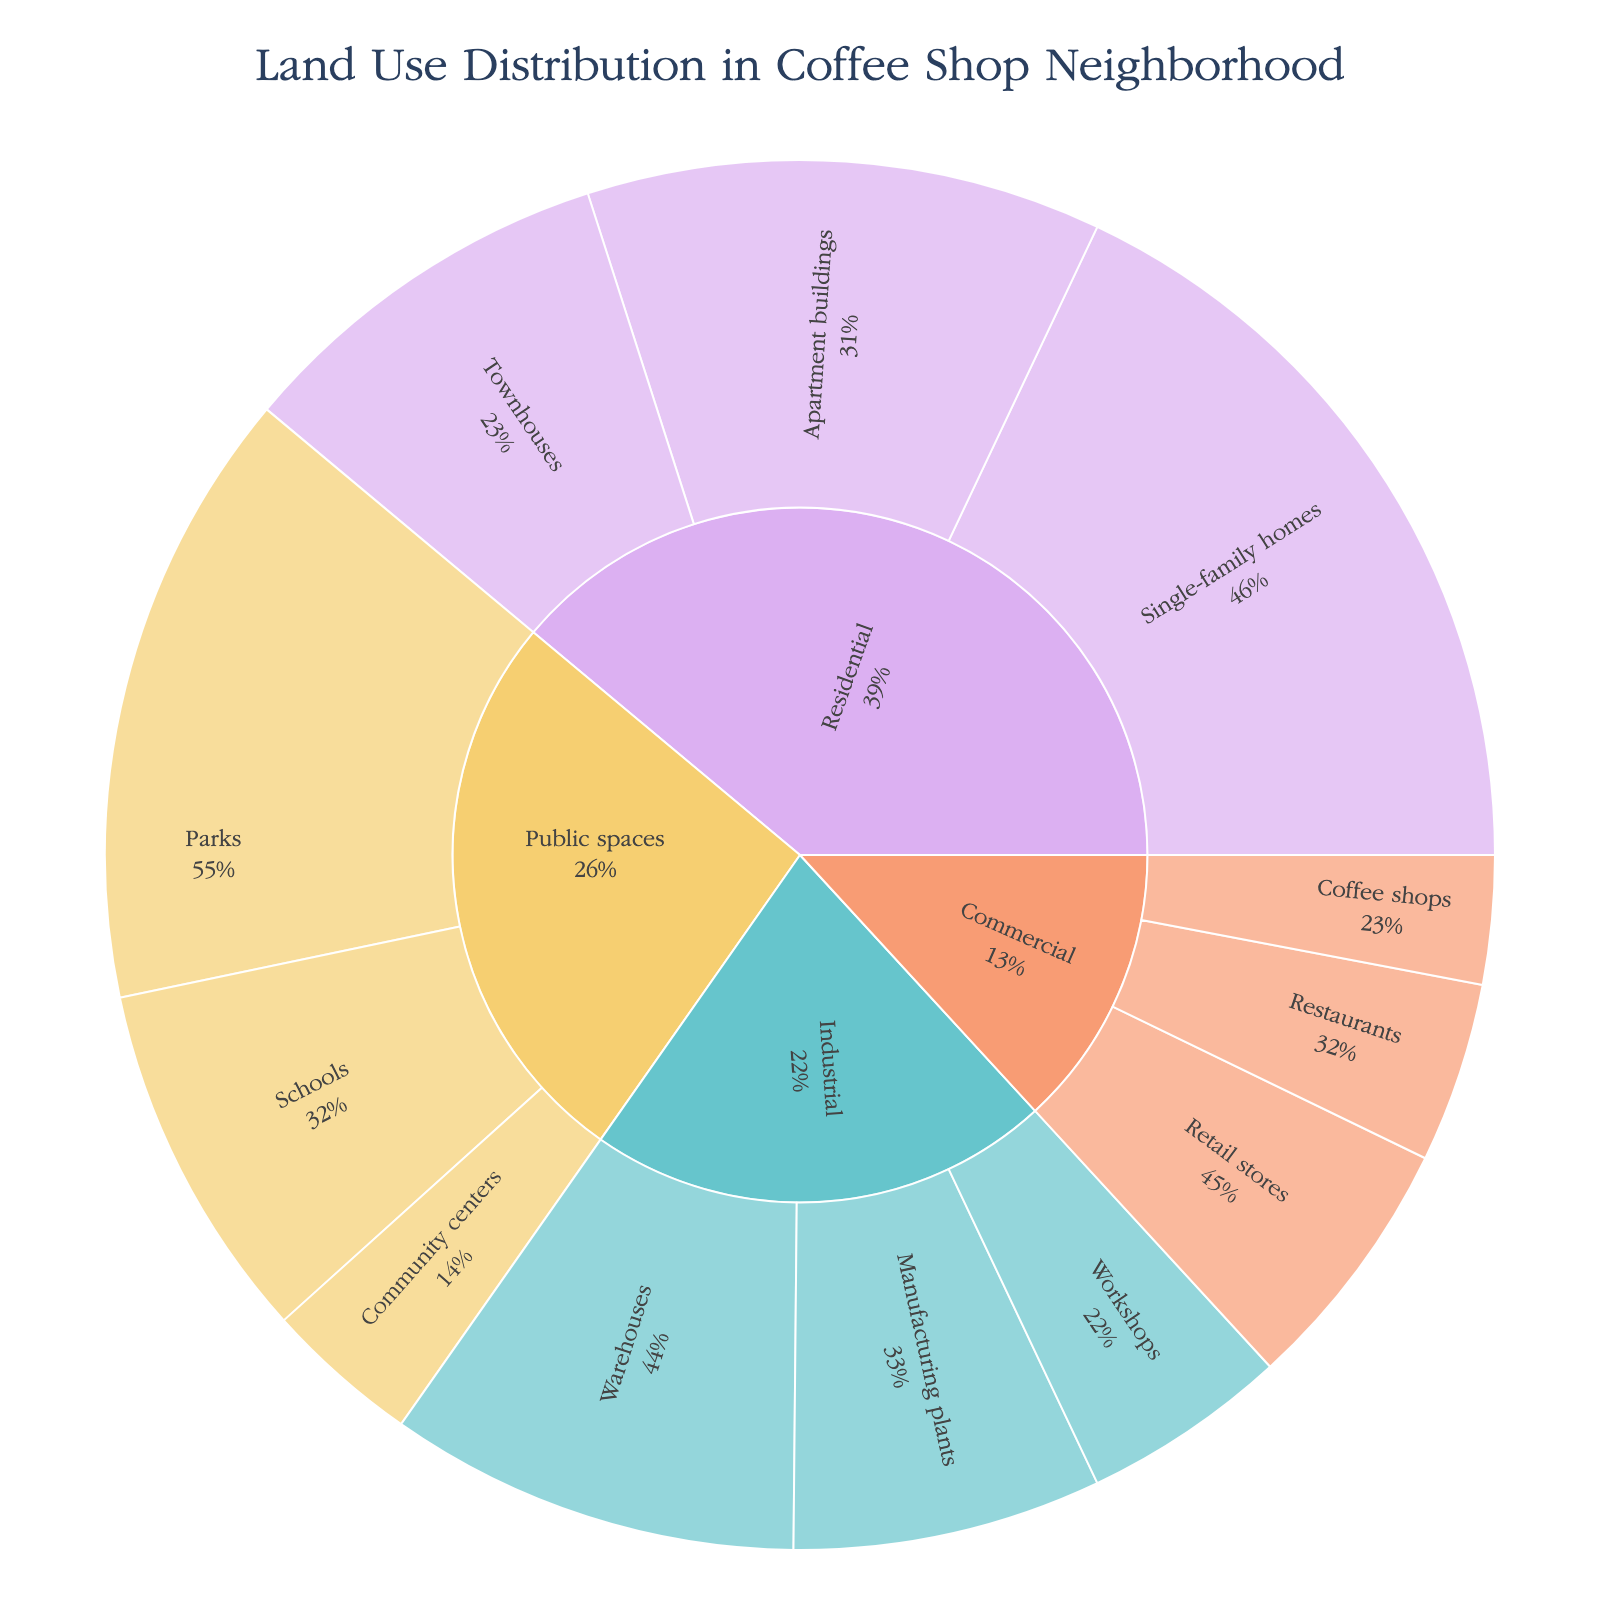What is the title of the sunburst chart? The title is displayed at the top of the chart. It usually provides context or summarizes what the chart represents.
Answer: Land Use Distribution in Coffee Shop Neighborhood Which category has the largest total area? Look at the largest segment in the innermost ring.
Answer: Residential How much area is allocated to parks? Hover over the segment labeled "Parks" to see the area displayed.
Answer: 120,000 sq.m What percentage of the total area do single-family homes occupy within the Residential category? Find the segment for "Single-family homes" within "Residential" and look at the percentage shown.
Answer: 42.9% Which category has the smallest total area, and what is it? Compare the innermost segments and find the smallest one.
Answer: Commercial, 110,000 sq.m How does the area of manufacturing plants compare to that of workshops? Look at the figures for both "Manufacturing plants" and "Workshops" under the "Industrial" category and compare their areas.
Answer: Manufacturing plants have 20,000 sq.m more area than workshops What is the combined area of Townhouses and Apartment buildings? Add the areas of "Townhouses" and "Apartment buildings" under "Residential."
Answer: 175,000 sq.m What type of land use occupies more area: public spaces or industrial areas? Compare the total areas shown for "Public spaces" and "Industrial" in the innermost ring.
Answer: Public spaces (220,000 sq.m) Within the commercial category, which subcategory occupies the most space? Look at the segments under "Commercial" and find the largest one.
Answer: Retail stores How is the text displayed on the segments labeled? Observe the text information on each segment to determine what's displayed.
Answer: Label and percent of parent 